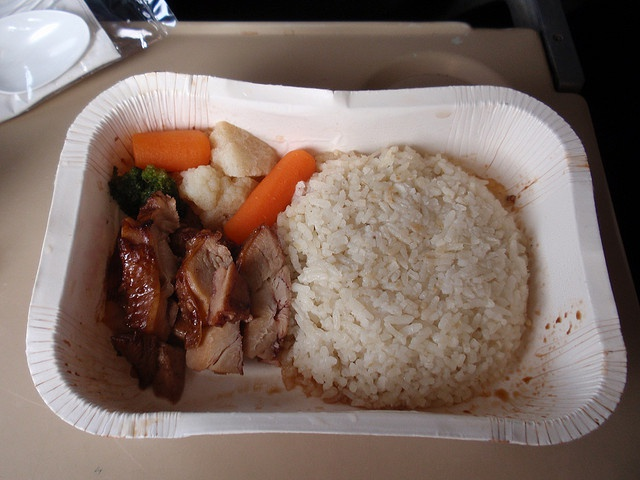Describe the objects in this image and their specific colors. I can see dining table in darkgray, gray, and maroon tones, bowl in darkgray, lightgray, gray, and maroon tones, spoon in darkgray, lavender, and lightgray tones, carrot in darkgray, red, brown, and maroon tones, and carrot in darkgray, brown, red, and maroon tones in this image. 